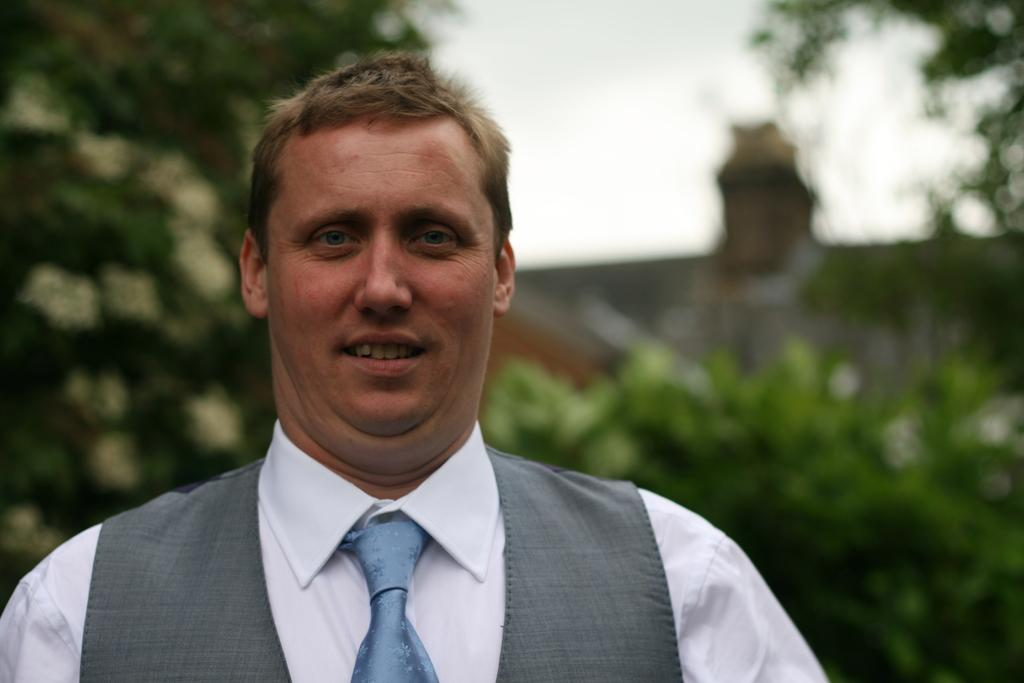What type of structure is present in the image? There is a building in the image. What can be seen in the background of the image? There are trees in the background of the image. Can you describe the person in the image? There is a man standing in the image. What is visible at the top of the image? The sky is visible in the image. What type of sponge is the man using to clean the building in the image? There is no sponge present in the image, nor is the man cleaning the building. 